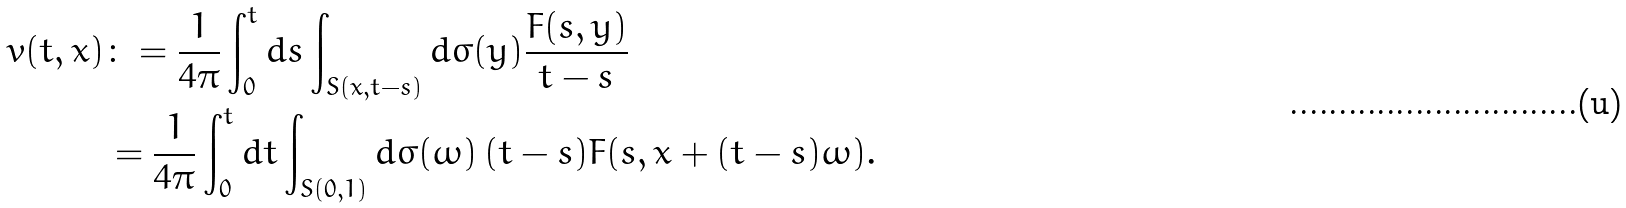Convert formula to latex. <formula><loc_0><loc_0><loc_500><loc_500>v ( t , x ) & \colon = \frac { 1 } { 4 \pi } \int _ { 0 } ^ { t } d s \int _ { S ( x , t - s ) } d \sigma ( y ) \frac { F ( s , y ) } { t - s } \\ & = \frac { 1 } { 4 \pi } \int _ { 0 } ^ { t } d t \int _ { S ( 0 , 1 ) } d \sigma ( \omega ) \, ( t - s ) F ( s , x + ( t - s ) \omega ) .</formula> 